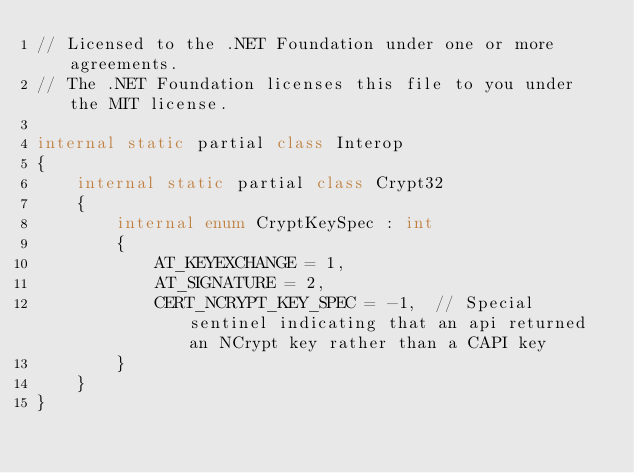Convert code to text. <code><loc_0><loc_0><loc_500><loc_500><_C#_>// Licensed to the .NET Foundation under one or more agreements.
// The .NET Foundation licenses this file to you under the MIT license.

internal static partial class Interop
{
    internal static partial class Crypt32
    {
        internal enum CryptKeySpec : int
        {
            AT_KEYEXCHANGE = 1,
            AT_SIGNATURE = 2,
            CERT_NCRYPT_KEY_SPEC = -1,  // Special sentinel indicating that an api returned an NCrypt key rather than a CAPI key
        }
    }
}
</code> 